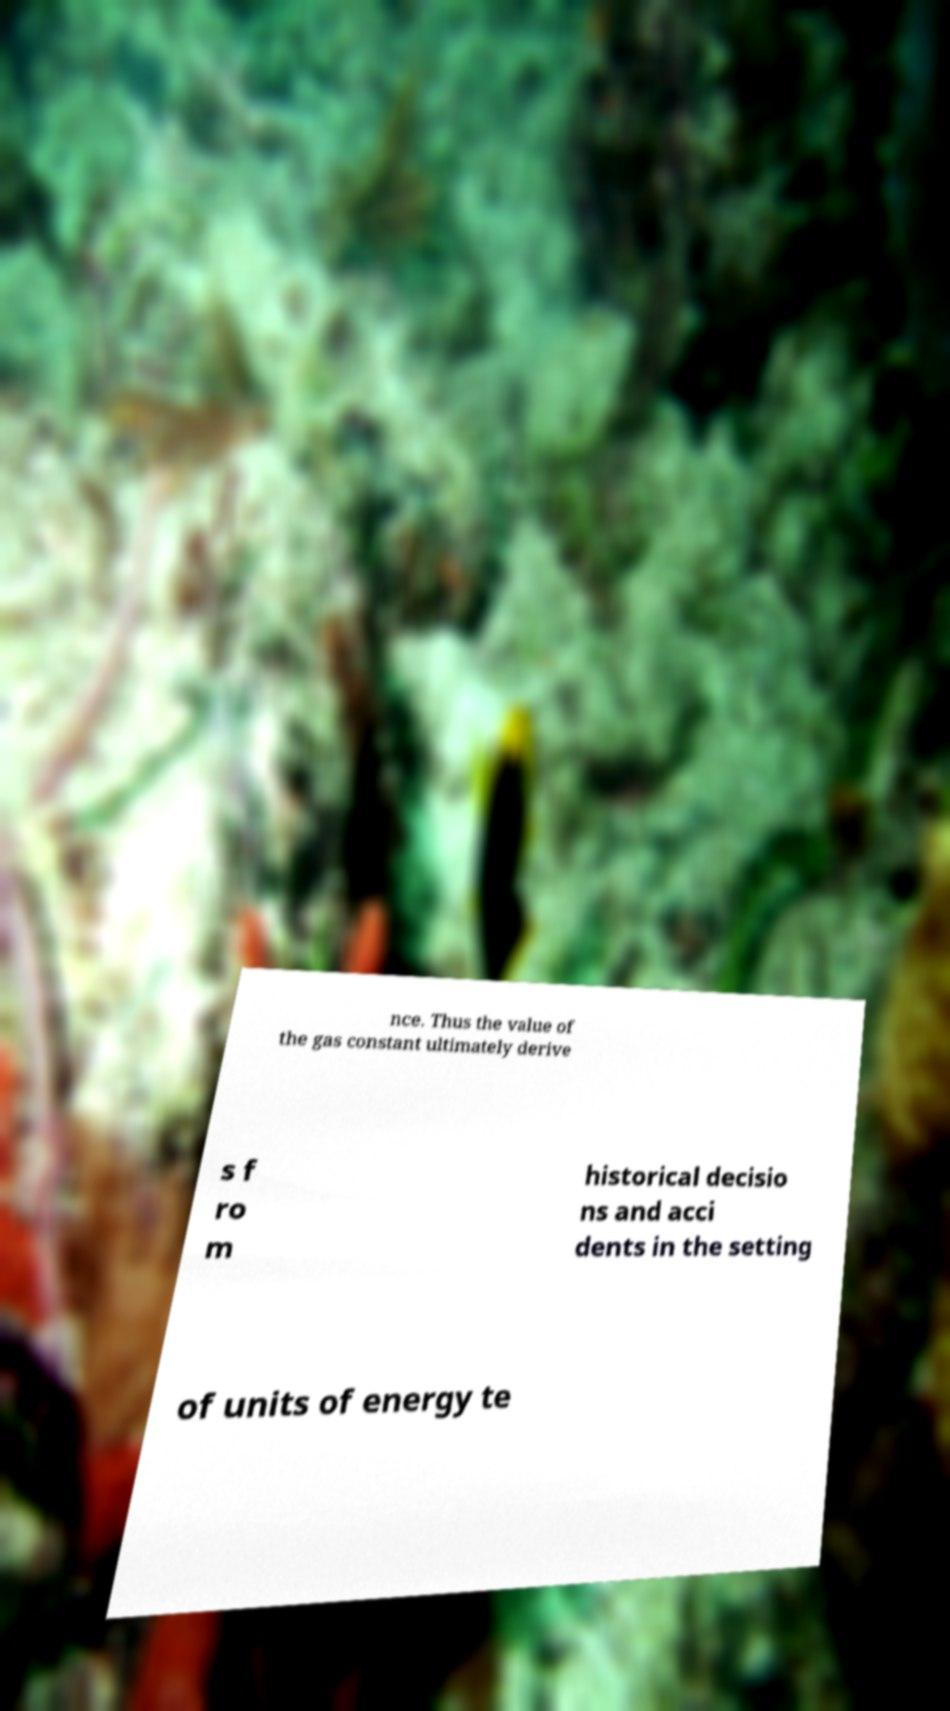I need the written content from this picture converted into text. Can you do that? nce. Thus the value of the gas constant ultimately derive s f ro m historical decisio ns and acci dents in the setting of units of energy te 